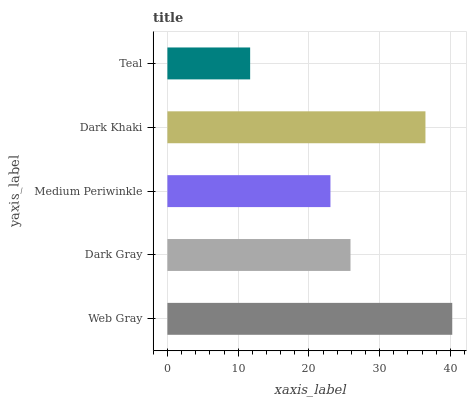Is Teal the minimum?
Answer yes or no. Yes. Is Web Gray the maximum?
Answer yes or no. Yes. Is Dark Gray the minimum?
Answer yes or no. No. Is Dark Gray the maximum?
Answer yes or no. No. Is Web Gray greater than Dark Gray?
Answer yes or no. Yes. Is Dark Gray less than Web Gray?
Answer yes or no. Yes. Is Dark Gray greater than Web Gray?
Answer yes or no. No. Is Web Gray less than Dark Gray?
Answer yes or no. No. Is Dark Gray the high median?
Answer yes or no. Yes. Is Dark Gray the low median?
Answer yes or no. Yes. Is Web Gray the high median?
Answer yes or no. No. Is Medium Periwinkle the low median?
Answer yes or no. No. 